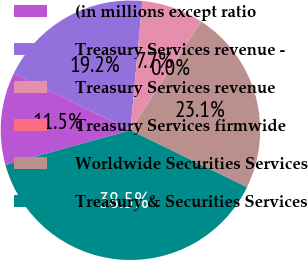<chart> <loc_0><loc_0><loc_500><loc_500><pie_chart><fcel>(in millions except ratio<fcel>Treasury Services revenue -<fcel>Treasury Services revenue<fcel>Treasury Services firmwide<fcel>Worldwide Securities Services<fcel>Treasury & Securities Services<nl><fcel>11.54%<fcel>19.23%<fcel>7.7%<fcel>0.01%<fcel>23.07%<fcel>38.45%<nl></chart> 